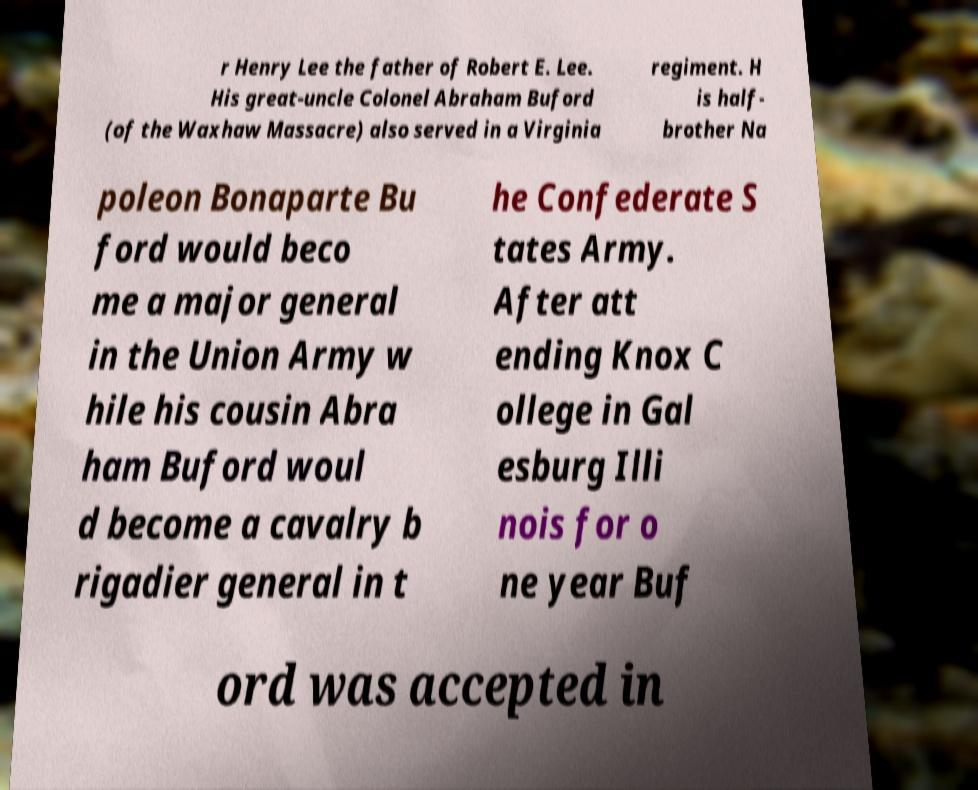What messages or text are displayed in this image? I need them in a readable, typed format. r Henry Lee the father of Robert E. Lee. His great-uncle Colonel Abraham Buford (of the Waxhaw Massacre) also served in a Virginia regiment. H is half- brother Na poleon Bonaparte Bu ford would beco me a major general in the Union Army w hile his cousin Abra ham Buford woul d become a cavalry b rigadier general in t he Confederate S tates Army. After att ending Knox C ollege in Gal esburg Illi nois for o ne year Buf ord was accepted in 